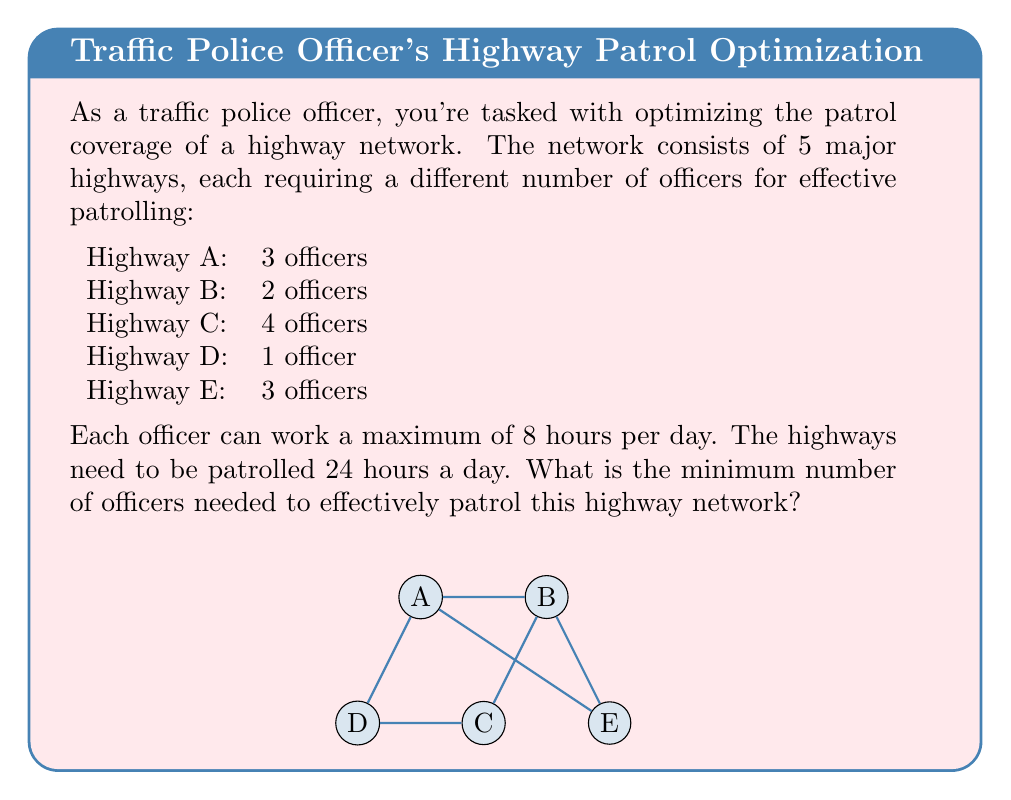Show me your answer to this math problem. To solve this optimization problem, we need to follow these steps:

1) First, calculate the total officer-hours needed per day for each highway:
   Highway A: $3 \times 24 = 72$ officer-hours
   Highway B: $2 \times 24 = 48$ officer-hours
   Highway C: $4 \times 24 = 96$ officer-hours
   Highway D: $1 \times 24 = 24$ officer-hours
   Highway E: $3 \times 24 = 72$ officer-hours

2) Sum up the total officer-hours needed for all highways:
   $72 + 48 + 96 + 24 + 72 = 312$ officer-hours

3) Since each officer can work a maximum of 8 hours per day, divide the total officer-hours by 8 to get the minimum number of officers needed:

   $$\text{Minimum officers} = \frac{\text{Total officer-hours}}{\text{Hours per officer}}$$
   
   $$\text{Minimum officers} = \frac{312}{8} = 39$$

4) Since we can't have a fractional number of officers, we need to round up to the nearest whole number.

Therefore, the minimum number of officers needed to effectively patrol this highway network is 39.
Answer: 39 officers 